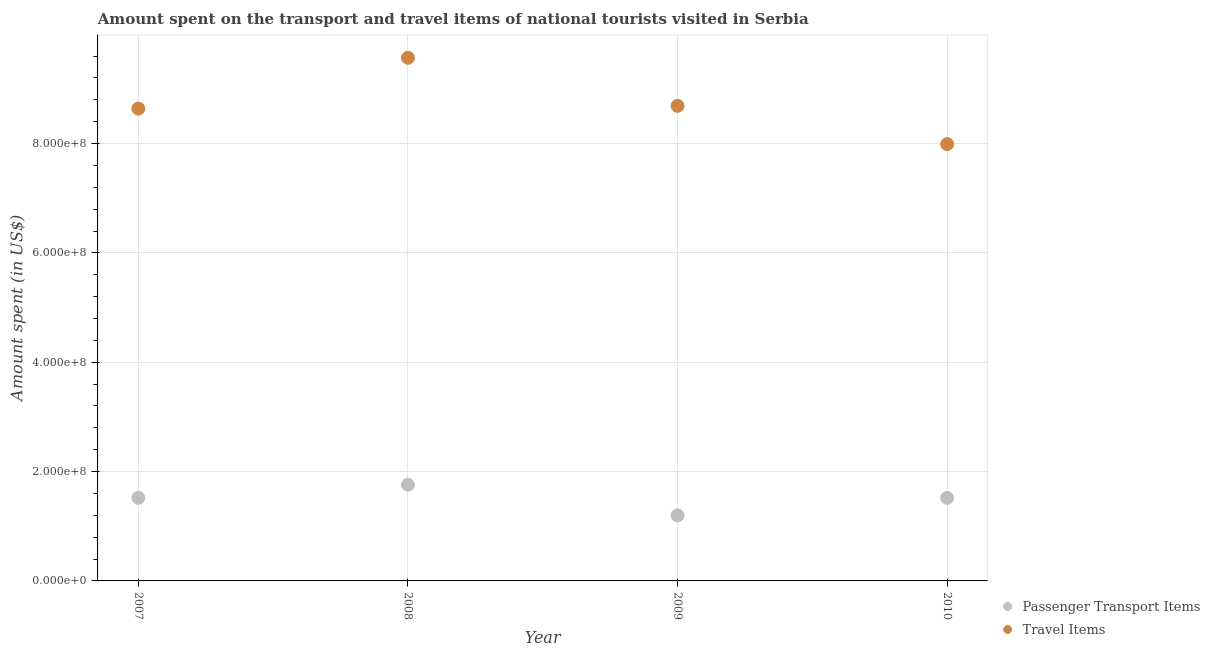How many different coloured dotlines are there?
Your answer should be very brief. 2. What is the amount spent in travel items in 2008?
Keep it short and to the point. 9.57e+08. Across all years, what is the maximum amount spent on passenger transport items?
Your response must be concise. 1.76e+08. Across all years, what is the minimum amount spent in travel items?
Provide a succinct answer. 7.99e+08. In which year was the amount spent in travel items minimum?
Your answer should be very brief. 2010. What is the total amount spent in travel items in the graph?
Offer a very short reply. 3.49e+09. What is the difference between the amount spent on passenger transport items in 2007 and that in 2008?
Offer a terse response. -2.40e+07. What is the difference between the amount spent on passenger transport items in 2007 and the amount spent in travel items in 2008?
Provide a succinct answer. -8.05e+08. What is the average amount spent in travel items per year?
Ensure brevity in your answer.  8.72e+08. In the year 2009, what is the difference between the amount spent on passenger transport items and amount spent in travel items?
Keep it short and to the point. -7.49e+08. In how many years, is the amount spent on passenger transport items greater than 200000000 US$?
Offer a very short reply. 0. What is the ratio of the amount spent in travel items in 2008 to that in 2010?
Your answer should be very brief. 1.2. Is the amount spent on passenger transport items in 2008 less than that in 2009?
Provide a short and direct response. No. Is the difference between the amount spent on passenger transport items in 2009 and 2010 greater than the difference between the amount spent in travel items in 2009 and 2010?
Make the answer very short. No. What is the difference between the highest and the second highest amount spent in travel items?
Offer a very short reply. 8.80e+07. What is the difference between the highest and the lowest amount spent on passenger transport items?
Provide a short and direct response. 5.60e+07. In how many years, is the amount spent on passenger transport items greater than the average amount spent on passenger transport items taken over all years?
Your answer should be very brief. 3. Is the amount spent in travel items strictly less than the amount spent on passenger transport items over the years?
Your response must be concise. No. Are the values on the major ticks of Y-axis written in scientific E-notation?
Your response must be concise. Yes. How many legend labels are there?
Provide a short and direct response. 2. What is the title of the graph?
Ensure brevity in your answer.  Amount spent on the transport and travel items of national tourists visited in Serbia. What is the label or title of the X-axis?
Make the answer very short. Year. What is the label or title of the Y-axis?
Offer a very short reply. Amount spent (in US$). What is the Amount spent (in US$) in Passenger Transport Items in 2007?
Give a very brief answer. 1.52e+08. What is the Amount spent (in US$) of Travel Items in 2007?
Make the answer very short. 8.64e+08. What is the Amount spent (in US$) in Passenger Transport Items in 2008?
Make the answer very short. 1.76e+08. What is the Amount spent (in US$) in Travel Items in 2008?
Ensure brevity in your answer.  9.57e+08. What is the Amount spent (in US$) in Passenger Transport Items in 2009?
Your response must be concise. 1.20e+08. What is the Amount spent (in US$) in Travel Items in 2009?
Keep it short and to the point. 8.69e+08. What is the Amount spent (in US$) in Passenger Transport Items in 2010?
Provide a succinct answer. 1.52e+08. What is the Amount spent (in US$) in Travel Items in 2010?
Your answer should be very brief. 7.99e+08. Across all years, what is the maximum Amount spent (in US$) of Passenger Transport Items?
Your response must be concise. 1.76e+08. Across all years, what is the maximum Amount spent (in US$) of Travel Items?
Your answer should be very brief. 9.57e+08. Across all years, what is the minimum Amount spent (in US$) in Passenger Transport Items?
Give a very brief answer. 1.20e+08. Across all years, what is the minimum Amount spent (in US$) of Travel Items?
Your answer should be compact. 7.99e+08. What is the total Amount spent (in US$) of Passenger Transport Items in the graph?
Your answer should be compact. 6.00e+08. What is the total Amount spent (in US$) of Travel Items in the graph?
Give a very brief answer. 3.49e+09. What is the difference between the Amount spent (in US$) of Passenger Transport Items in 2007 and that in 2008?
Your answer should be very brief. -2.40e+07. What is the difference between the Amount spent (in US$) in Travel Items in 2007 and that in 2008?
Your response must be concise. -9.30e+07. What is the difference between the Amount spent (in US$) in Passenger Transport Items in 2007 and that in 2009?
Your answer should be compact. 3.20e+07. What is the difference between the Amount spent (in US$) in Travel Items in 2007 and that in 2009?
Provide a short and direct response. -5.00e+06. What is the difference between the Amount spent (in US$) in Passenger Transport Items in 2007 and that in 2010?
Offer a very short reply. 0. What is the difference between the Amount spent (in US$) in Travel Items in 2007 and that in 2010?
Your answer should be very brief. 6.50e+07. What is the difference between the Amount spent (in US$) of Passenger Transport Items in 2008 and that in 2009?
Offer a very short reply. 5.60e+07. What is the difference between the Amount spent (in US$) of Travel Items in 2008 and that in 2009?
Your response must be concise. 8.80e+07. What is the difference between the Amount spent (in US$) of Passenger Transport Items in 2008 and that in 2010?
Offer a very short reply. 2.40e+07. What is the difference between the Amount spent (in US$) of Travel Items in 2008 and that in 2010?
Make the answer very short. 1.58e+08. What is the difference between the Amount spent (in US$) in Passenger Transport Items in 2009 and that in 2010?
Keep it short and to the point. -3.20e+07. What is the difference between the Amount spent (in US$) of Travel Items in 2009 and that in 2010?
Provide a succinct answer. 7.00e+07. What is the difference between the Amount spent (in US$) in Passenger Transport Items in 2007 and the Amount spent (in US$) in Travel Items in 2008?
Give a very brief answer. -8.05e+08. What is the difference between the Amount spent (in US$) in Passenger Transport Items in 2007 and the Amount spent (in US$) in Travel Items in 2009?
Provide a succinct answer. -7.17e+08. What is the difference between the Amount spent (in US$) of Passenger Transport Items in 2007 and the Amount spent (in US$) of Travel Items in 2010?
Offer a very short reply. -6.47e+08. What is the difference between the Amount spent (in US$) of Passenger Transport Items in 2008 and the Amount spent (in US$) of Travel Items in 2009?
Offer a terse response. -6.93e+08. What is the difference between the Amount spent (in US$) in Passenger Transport Items in 2008 and the Amount spent (in US$) in Travel Items in 2010?
Ensure brevity in your answer.  -6.23e+08. What is the difference between the Amount spent (in US$) in Passenger Transport Items in 2009 and the Amount spent (in US$) in Travel Items in 2010?
Offer a terse response. -6.79e+08. What is the average Amount spent (in US$) in Passenger Transport Items per year?
Provide a succinct answer. 1.50e+08. What is the average Amount spent (in US$) in Travel Items per year?
Ensure brevity in your answer.  8.72e+08. In the year 2007, what is the difference between the Amount spent (in US$) in Passenger Transport Items and Amount spent (in US$) in Travel Items?
Make the answer very short. -7.12e+08. In the year 2008, what is the difference between the Amount spent (in US$) of Passenger Transport Items and Amount spent (in US$) of Travel Items?
Make the answer very short. -7.81e+08. In the year 2009, what is the difference between the Amount spent (in US$) of Passenger Transport Items and Amount spent (in US$) of Travel Items?
Give a very brief answer. -7.49e+08. In the year 2010, what is the difference between the Amount spent (in US$) of Passenger Transport Items and Amount spent (in US$) of Travel Items?
Provide a succinct answer. -6.47e+08. What is the ratio of the Amount spent (in US$) of Passenger Transport Items in 2007 to that in 2008?
Your answer should be very brief. 0.86. What is the ratio of the Amount spent (in US$) in Travel Items in 2007 to that in 2008?
Your response must be concise. 0.9. What is the ratio of the Amount spent (in US$) in Passenger Transport Items in 2007 to that in 2009?
Offer a terse response. 1.27. What is the ratio of the Amount spent (in US$) in Passenger Transport Items in 2007 to that in 2010?
Provide a short and direct response. 1. What is the ratio of the Amount spent (in US$) in Travel Items in 2007 to that in 2010?
Provide a short and direct response. 1.08. What is the ratio of the Amount spent (in US$) in Passenger Transport Items in 2008 to that in 2009?
Your answer should be compact. 1.47. What is the ratio of the Amount spent (in US$) in Travel Items in 2008 to that in 2009?
Your answer should be very brief. 1.1. What is the ratio of the Amount spent (in US$) in Passenger Transport Items in 2008 to that in 2010?
Provide a short and direct response. 1.16. What is the ratio of the Amount spent (in US$) of Travel Items in 2008 to that in 2010?
Keep it short and to the point. 1.2. What is the ratio of the Amount spent (in US$) in Passenger Transport Items in 2009 to that in 2010?
Provide a short and direct response. 0.79. What is the ratio of the Amount spent (in US$) of Travel Items in 2009 to that in 2010?
Provide a succinct answer. 1.09. What is the difference between the highest and the second highest Amount spent (in US$) in Passenger Transport Items?
Keep it short and to the point. 2.40e+07. What is the difference between the highest and the second highest Amount spent (in US$) in Travel Items?
Provide a succinct answer. 8.80e+07. What is the difference between the highest and the lowest Amount spent (in US$) in Passenger Transport Items?
Your response must be concise. 5.60e+07. What is the difference between the highest and the lowest Amount spent (in US$) in Travel Items?
Your answer should be very brief. 1.58e+08. 